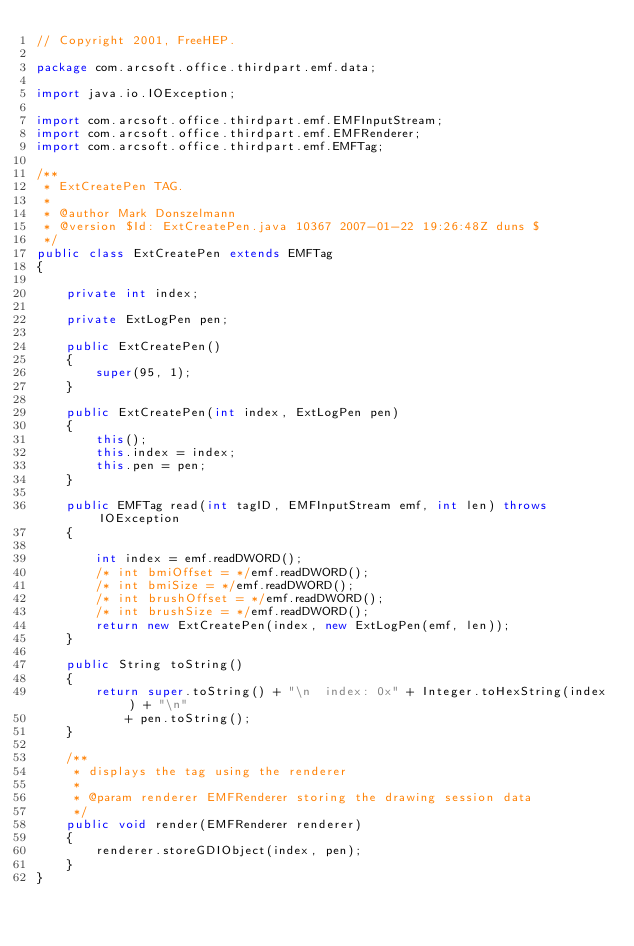<code> <loc_0><loc_0><loc_500><loc_500><_Java_>// Copyright 2001, FreeHEP.

package com.arcsoft.office.thirdpart.emf.data;

import java.io.IOException;

import com.arcsoft.office.thirdpart.emf.EMFInputStream;
import com.arcsoft.office.thirdpart.emf.EMFRenderer;
import com.arcsoft.office.thirdpart.emf.EMFTag;

/**
 * ExtCreatePen TAG.
 * 
 * @author Mark Donszelmann
 * @version $Id: ExtCreatePen.java 10367 2007-01-22 19:26:48Z duns $
 */
public class ExtCreatePen extends EMFTag
{

    private int index;

    private ExtLogPen pen;

    public ExtCreatePen()
    {
        super(95, 1);
    }

    public ExtCreatePen(int index, ExtLogPen pen)
    {
        this();
        this.index = index;
        this.pen = pen;
    }

    public EMFTag read(int tagID, EMFInputStream emf, int len) throws IOException
    {

        int index = emf.readDWORD();
        /* int bmiOffset = */emf.readDWORD();
        /* int bmiSize = */emf.readDWORD();
        /* int brushOffset = */emf.readDWORD();
        /* int brushSize = */emf.readDWORD();
        return new ExtCreatePen(index, new ExtLogPen(emf, len));
    }

    public String toString()
    {
        return super.toString() + "\n  index: 0x" + Integer.toHexString(index) + "\n"
            + pen.toString();
    }

    /**
     * displays the tag using the renderer
     *
     * @param renderer EMFRenderer storing the drawing session data
     */
    public void render(EMFRenderer renderer)
    {
        renderer.storeGDIObject(index, pen);
    }
}
</code> 